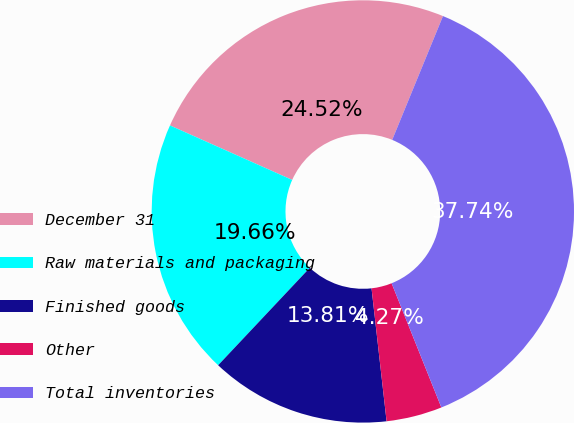Convert chart to OTSL. <chart><loc_0><loc_0><loc_500><loc_500><pie_chart><fcel>December 31<fcel>Raw materials and packaging<fcel>Finished goods<fcel>Other<fcel>Total inventories<nl><fcel>24.52%<fcel>19.66%<fcel>13.81%<fcel>4.27%<fcel>37.74%<nl></chart> 